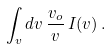Convert formula to latex. <formula><loc_0><loc_0><loc_500><loc_500>\int _ { v } d v \, \frac { v _ { o } } { v } \, I ( v ) \, .</formula> 